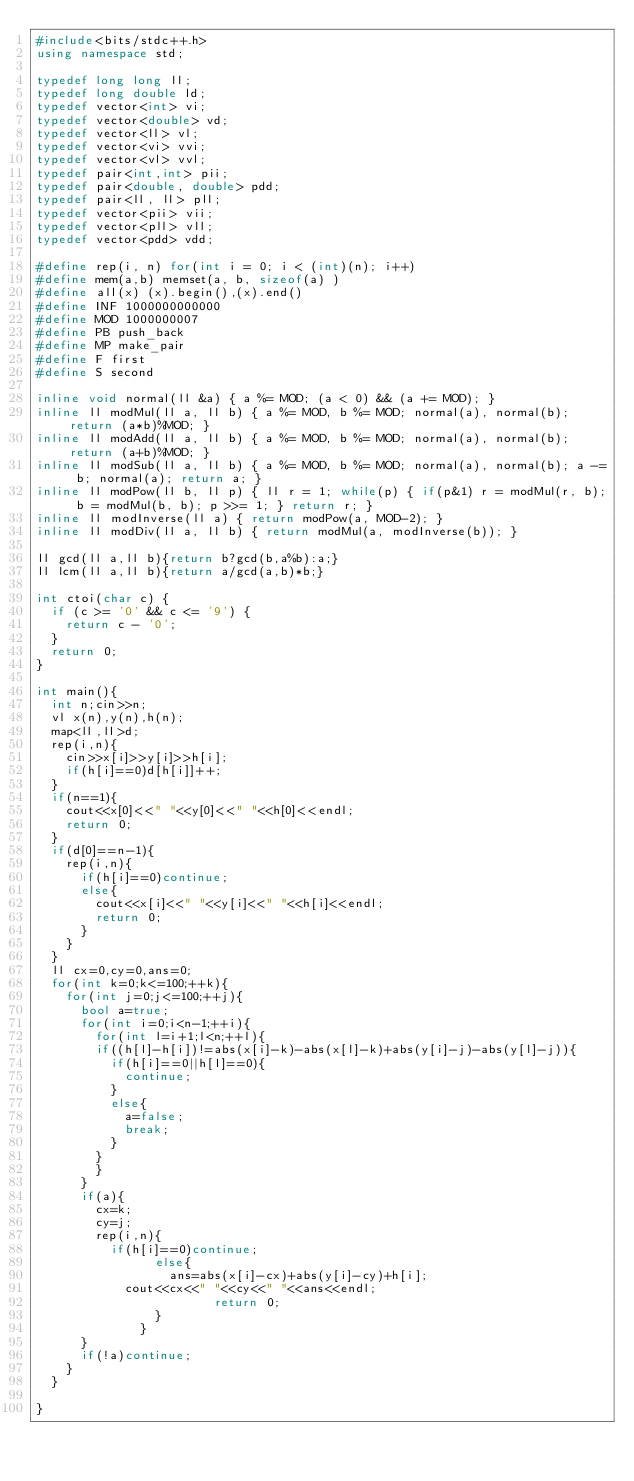Convert code to text. <code><loc_0><loc_0><loc_500><loc_500><_C++_>#include<bits/stdc++.h>
using namespace std;

typedef long long ll;
typedef long double ld;
typedef vector<int> vi;
typedef vector<double> vd;
typedef vector<ll> vl;
typedef vector<vi> vvi;
typedef vector<vl> vvl;
typedef pair<int,int> pii;
typedef pair<double, double> pdd;
typedef pair<ll, ll> pll;
typedef vector<pii> vii;
typedef vector<pll> vll;
typedef vector<pdd> vdd;

#define rep(i, n) for(int i = 0; i < (int)(n); i++)
#define mem(a,b) memset(a, b, sizeof(a) )
#define all(x) (x).begin(),(x).end()
#define INF 1000000000000
#define MOD 1000000007
#define PB push_back
#define MP make_pair
#define F first
#define S second

inline void normal(ll &a) { a %= MOD; (a < 0) && (a += MOD); }
inline ll modMul(ll a, ll b) { a %= MOD, b %= MOD; normal(a), normal(b); return (a*b)%MOD; }
inline ll modAdd(ll a, ll b) { a %= MOD, b %= MOD; normal(a), normal(b); return (a+b)%MOD; }
inline ll modSub(ll a, ll b) { a %= MOD, b %= MOD; normal(a), normal(b); a -= b; normal(a); return a; }
inline ll modPow(ll b, ll p) { ll r = 1; while(p) { if(p&1) r = modMul(r, b); b = modMul(b, b); p >>= 1; } return r; }
inline ll modInverse(ll a) { return modPow(a, MOD-2); }
inline ll modDiv(ll a, ll b) { return modMul(a, modInverse(b)); }

ll gcd(ll a,ll b){return b?gcd(b,a%b):a;}
ll lcm(ll a,ll b){return a/gcd(a,b)*b;}

int ctoi(char c) {
	if (c >= '0' && c <= '9') {
		return c - '0';
	}
	return 0;
}

int main(){
	int n;cin>>n;
	vl x(n),y(n),h(n);
	map<ll,ll>d;
	rep(i,n){
		cin>>x[i]>>y[i]>>h[i];
		if(h[i]==0)d[h[i]]++;
	}
	if(n==1){
		cout<<x[0]<<" "<<y[0]<<" "<<h[0]<<endl;
		return 0;
	}
	if(d[0]==n-1){
		rep(i,n){
			if(h[i]==0)continue;
			else{
				cout<<x[i]<<" "<<y[i]<<" "<<h[i]<<endl;
				return 0;
			}
		}
	}
	ll cx=0,cy=0,ans=0;
	for(int k=0;k<=100;++k){
		for(int j=0;j<=100;++j){
			bool a=true;
			for(int i=0;i<n-1;++i){
				for(int l=i+1;l<n;++l){
				if((h[l]-h[i])!=abs(x[i]-k)-abs(x[l]-k)+abs(y[i]-j)-abs(y[l]-j)){
					if(h[i]==0||h[l]==0){
						continue;
					}
					else{
						a=false;
						break;
					}
				}
				}
			}
			if(a){
				cx=k;
				cy=j;
				rep(i,n){
					if(h[i]==0)continue;
		            else{
			            ans=abs(x[i]-cx)+abs(y[i]-cy)+h[i];
						cout<<cx<<" "<<cy<<" "<<ans<<endl;
                        return 0;
		            }
            	}
			}
			if(!a)continue;
		}
	}
	
}
</code> 